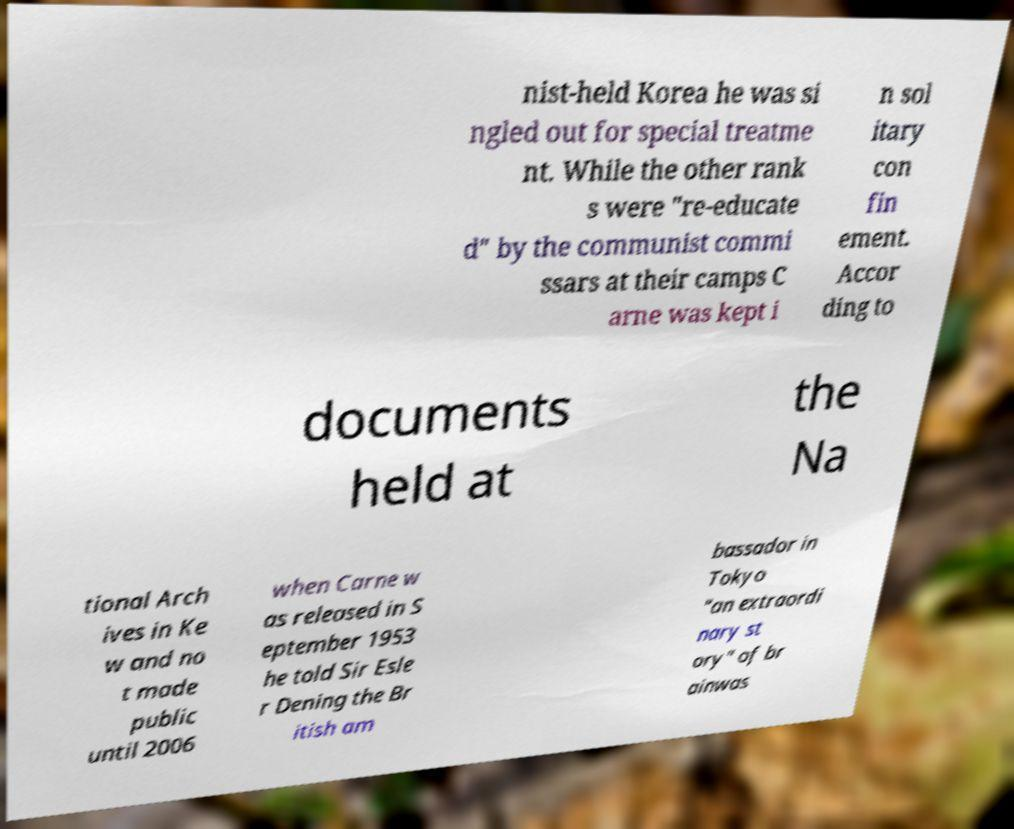Please identify and transcribe the text found in this image. nist-held Korea he was si ngled out for special treatme nt. While the other rank s were "re-educate d" by the communist commi ssars at their camps C arne was kept i n sol itary con fin ement. Accor ding to documents held at the Na tional Arch ives in Ke w and no t made public until 2006 when Carne w as released in S eptember 1953 he told Sir Esle r Dening the Br itish am bassador in Tokyo "an extraordi nary st ory" of br ainwas 